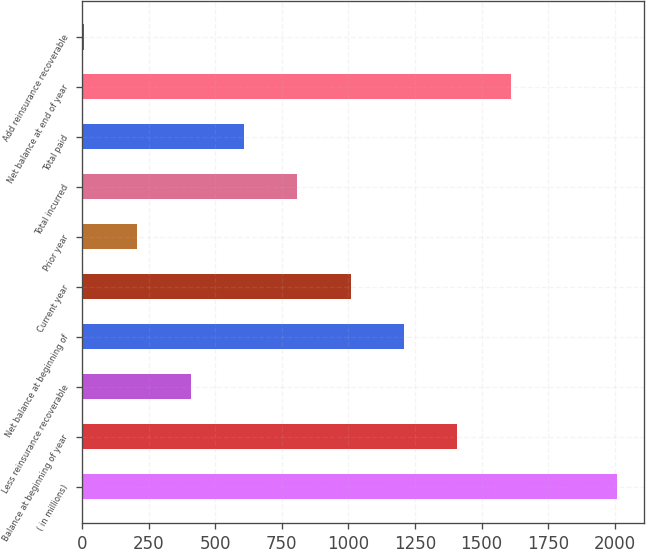Convert chart to OTSL. <chart><loc_0><loc_0><loc_500><loc_500><bar_chart><fcel>( in millions)<fcel>Balance at beginning of year<fcel>Less reinsurance recoverable<fcel>Net balance at beginning of<fcel>Current year<fcel>Prior year<fcel>Total incurred<fcel>Total paid<fcel>Net balance at end of year<fcel>Add reinsurance recoverable<nl><fcel>2010<fcel>1409.1<fcel>407.6<fcel>1208.8<fcel>1008.5<fcel>207.3<fcel>808.2<fcel>607.9<fcel>1609.4<fcel>7<nl></chart> 